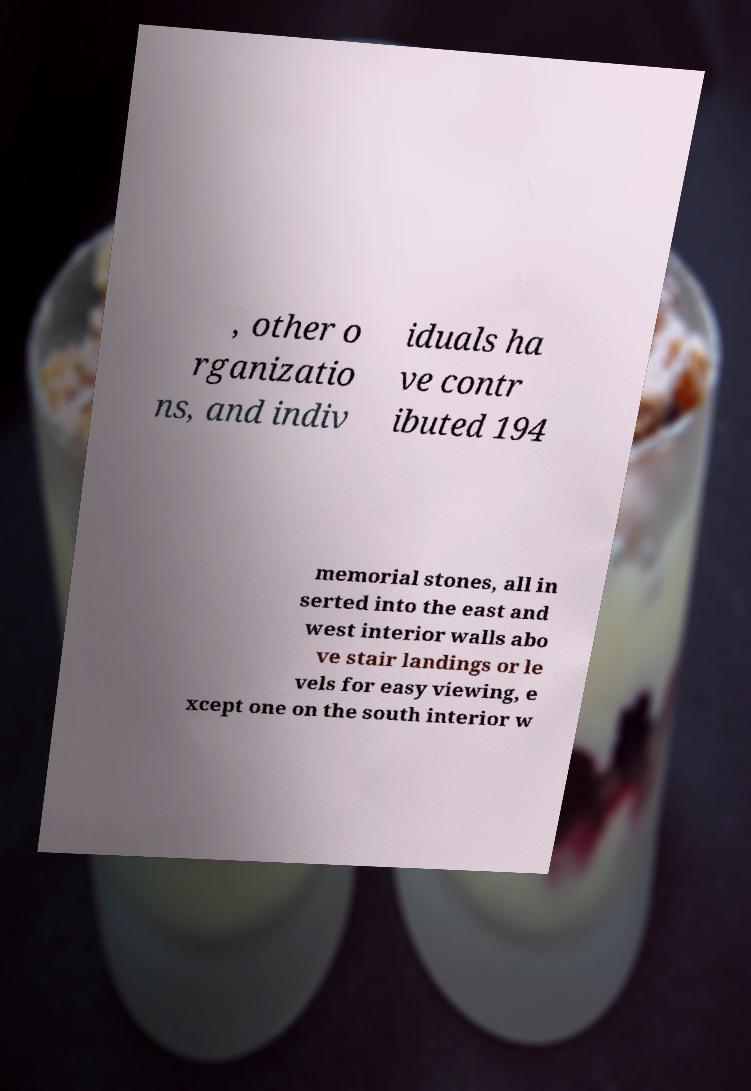For documentation purposes, I need the text within this image transcribed. Could you provide that? , other o rganizatio ns, and indiv iduals ha ve contr ibuted 194 memorial stones, all in serted into the east and west interior walls abo ve stair landings or le vels for easy viewing, e xcept one on the south interior w 